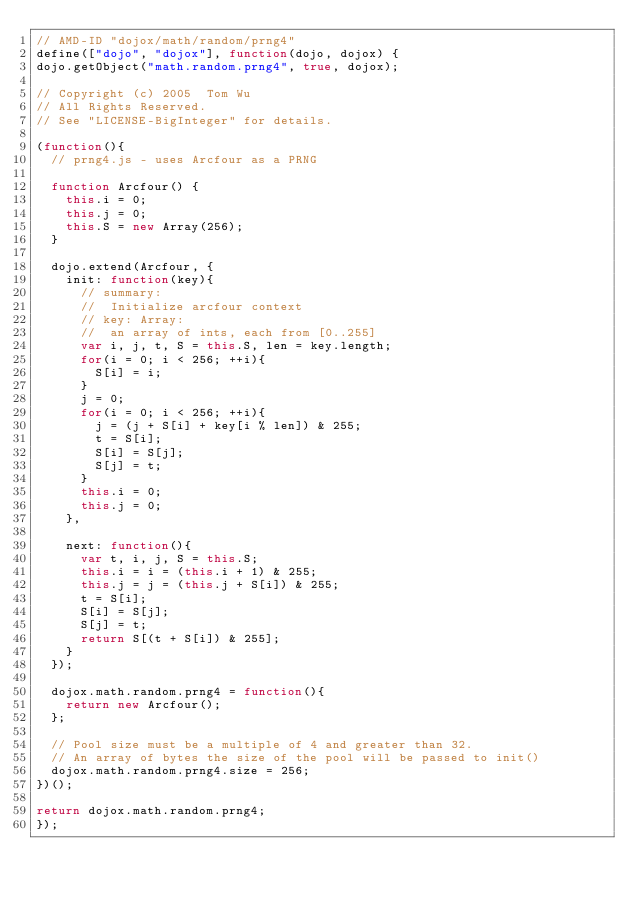Convert code to text. <code><loc_0><loc_0><loc_500><loc_500><_JavaScript_>// AMD-ID "dojox/math/random/prng4"
define(["dojo", "dojox"], function(dojo, dojox) {
dojo.getObject("math.random.prng4", true, dojox);

// Copyright (c) 2005  Tom Wu
// All Rights Reserved.
// See "LICENSE-BigInteger" for details.

(function(){
	// prng4.js - uses Arcfour as a PRNG

	function Arcfour() {
		this.i = 0;
		this.j = 0;
		this.S = new Array(256);
	}

	dojo.extend(Arcfour, {
		init: function(key){
			// summary:
			//	Initialize arcfour context
			// key: Array:
			//	an array of ints, each from [0..255]
			var i, j, t, S = this.S, len = key.length;
			for(i = 0; i < 256; ++i){
				S[i] = i;
			}
			j = 0;
			for(i = 0; i < 256; ++i){
				j = (j + S[i] + key[i % len]) & 255;
				t = S[i];
				S[i] = S[j];
				S[j] = t;
			}
			this.i = 0;
			this.j = 0;
		},

		next: function(){
			var t, i, j, S = this.S;
			this.i = i = (this.i + 1) & 255;
			this.j = j = (this.j + S[i]) & 255;
			t = S[i];
			S[i] = S[j];
			S[j] = t;
			return S[(t + S[i]) & 255];
		}
	});

	dojox.math.random.prng4 = function(){
		return new Arcfour();
	};

	// Pool size must be a multiple of 4 and greater than 32.
	// An array of bytes the size of the pool will be passed to init()
	dojox.math.random.prng4.size = 256;
})();

return dojox.math.random.prng4;
});
</code> 